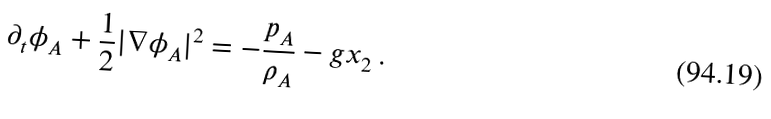Convert formula to latex. <formula><loc_0><loc_0><loc_500><loc_500>\partial _ { t } \phi _ { A } + \frac { 1 } { 2 } | \nabla \phi _ { A } | ^ { 2 } = - \frac { p _ { A } } { \rho _ { A } } - g x _ { 2 } \, .</formula> 